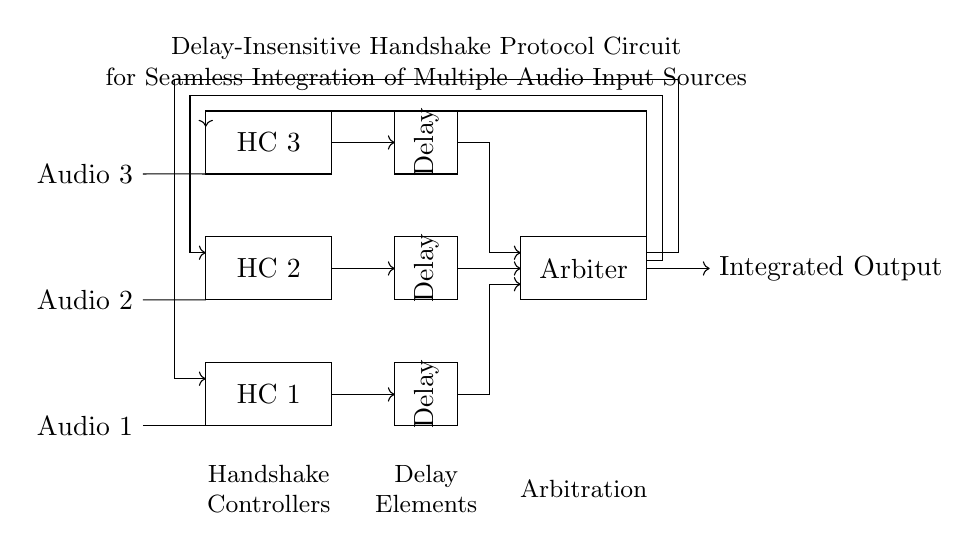What are the three audio input sources? The circuit diagram shows three audio input sources labeled as Audio 1, Audio 2, and Audio 3, each located on the left side of the circuit.
Answer: Audio 1, Audio 2, Audio 3 What do the rectangles labeled HC represent? The rectangles labeled HC in the circuit signify Handshake Controllers, which manage the handshake communication between the audio input sources and the following elements in the circuit.
Answer: Handshake Controllers How many delay elements are present in the circuit? The circuit contains three delay elements, indicated by rectangles labeled "Delay" next to each handshake controller, which introduce a specific timing delay in the signal path.
Answer: Three What is the function of the Arbiter in this circuit? The Arbiter is a component that processes the signals from the delay elements and controls which audio input source’s signal will be sent to the integrated output based on the delay-insensitive handshake protocol.
Answer: Input selection Describe the connection type used between the Handshake Controllers and Delay Elements. The Handshake Controllers are connected to the Delay Elements via unidirectional arrows, indicating that the signal only flows in one direction, from the Handshake Controllers to the Delay Elements, which is crucial for the circuit's asynchronous behavior.
Answer: Unidirectional What is the integrated output labeled as? The integrated output of the circuit is labeled simply as "Integrated Output," which represents the final stage where the selected audio input sources are combined into a single output.
Answer: Integrated Output How does feedback occur in this circuit? Feedback paths are represented with arrows pointing in the opposite direction from the output back to the audio sources, ensuring that any changes in the integrated output can influence the input sources by getting their status updated through the feedback connections.
Answer: Feedback paths 